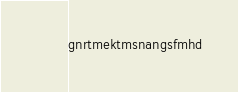Convert code to text. <code><loc_0><loc_0><loc_500><loc_500><_C#_>gnrtmektmsnangsfmhd</code> 